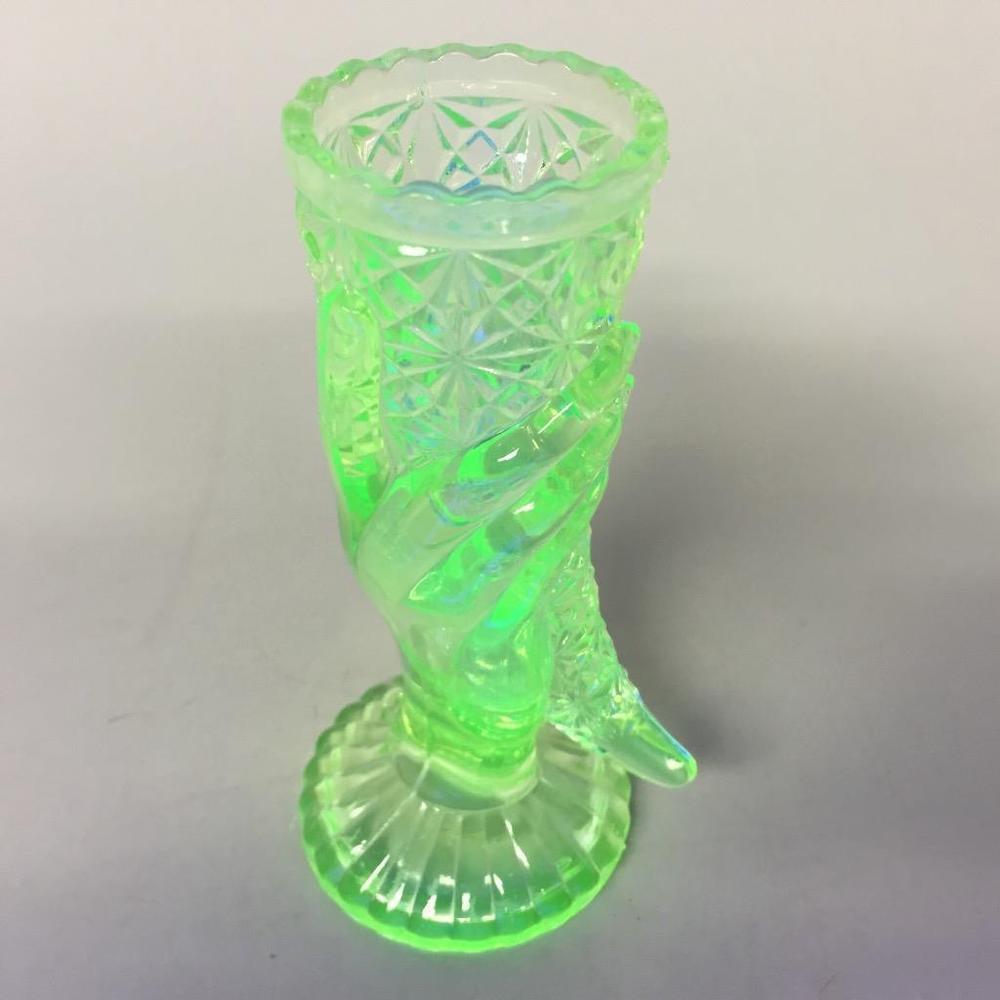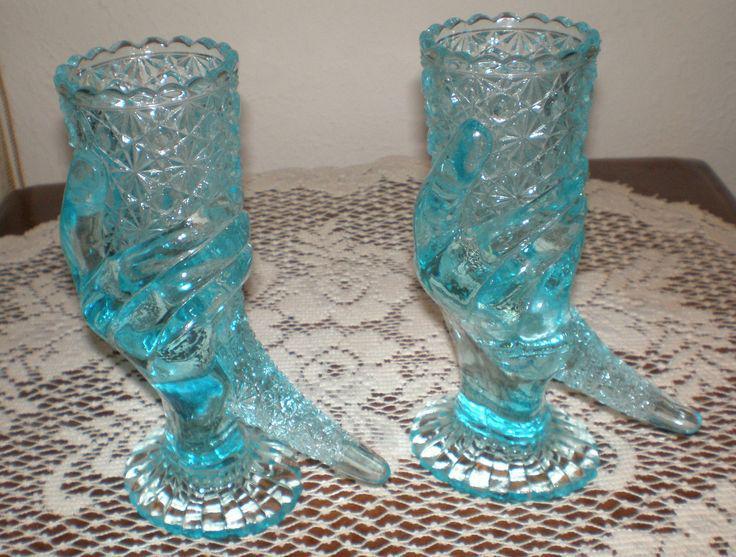The first image is the image on the left, the second image is the image on the right. Examine the images to the left and right. Is the description "The right image contains two glass sculptures." accurate? Answer yes or no. Yes. The first image is the image on the left, the second image is the image on the right. Assess this claim about the two images: "The left image shows one vase that tapers to a wave-curl at its bottom, and the right image shows at least one vase with a rounded bottom and no curl.". Correct or not? Answer yes or no. No. 